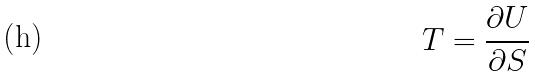Convert formula to latex. <formula><loc_0><loc_0><loc_500><loc_500>T = \frac { \partial U } { \partial S }</formula> 